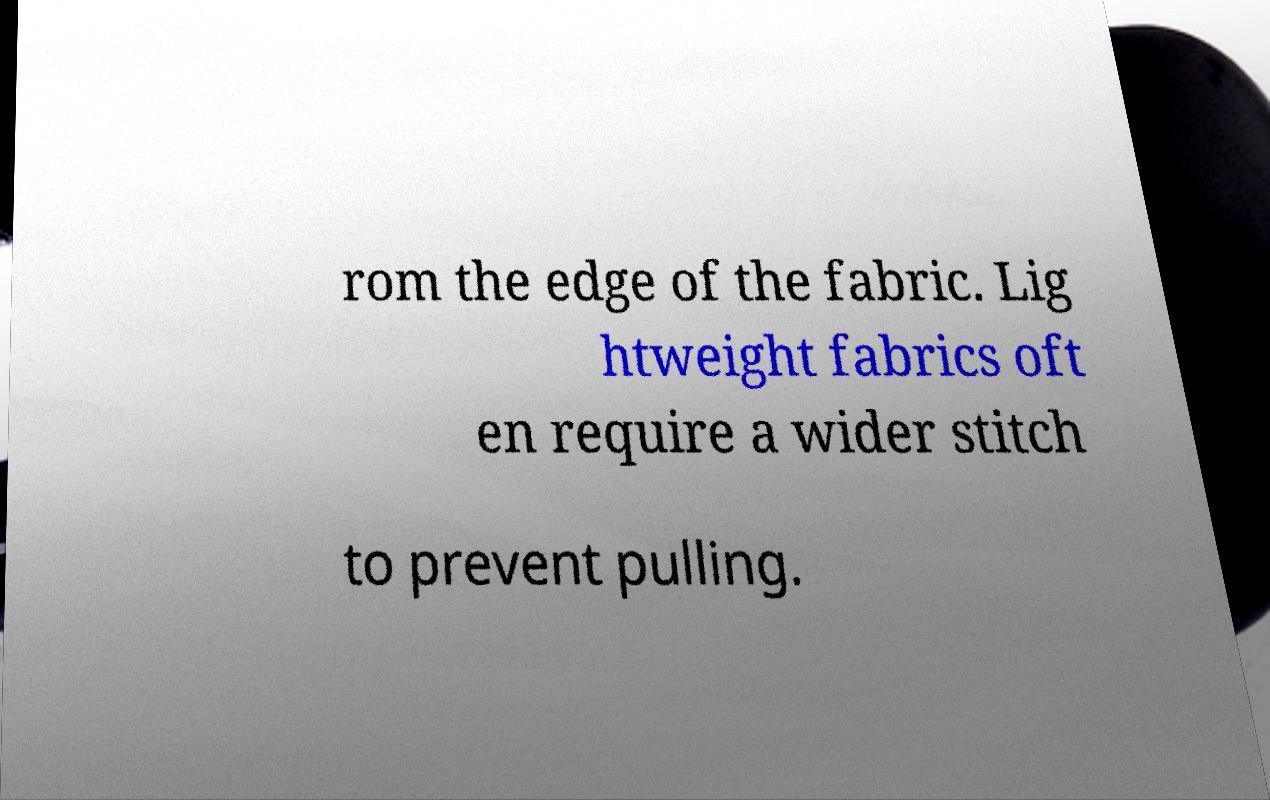For documentation purposes, I need the text within this image transcribed. Could you provide that? rom the edge of the fabric. Lig htweight fabrics oft en require a wider stitch to prevent pulling. 